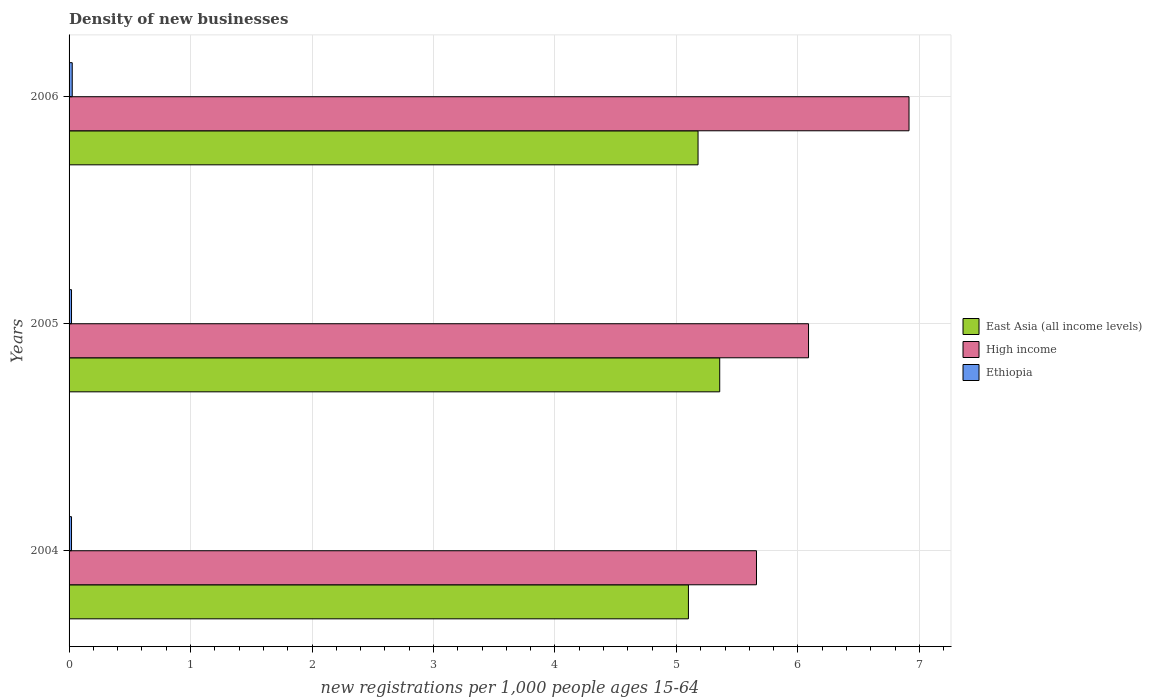How many groups of bars are there?
Your response must be concise. 3. How many bars are there on the 1st tick from the top?
Your response must be concise. 3. How many bars are there on the 2nd tick from the bottom?
Make the answer very short. 3. What is the label of the 1st group of bars from the top?
Offer a very short reply. 2006. In how many cases, is the number of bars for a given year not equal to the number of legend labels?
Your answer should be very brief. 0. What is the number of new registrations in Ethiopia in 2006?
Ensure brevity in your answer.  0.03. Across all years, what is the maximum number of new registrations in High income?
Offer a terse response. 6.91. Across all years, what is the minimum number of new registrations in East Asia (all income levels)?
Offer a very short reply. 5.1. In which year was the number of new registrations in High income maximum?
Your response must be concise. 2006. What is the total number of new registrations in Ethiopia in the graph?
Provide a succinct answer. 0.07. What is the difference between the number of new registrations in East Asia (all income levels) in 2005 and that in 2006?
Offer a very short reply. 0.18. What is the difference between the number of new registrations in High income in 2004 and the number of new registrations in East Asia (all income levels) in 2005?
Give a very brief answer. 0.3. What is the average number of new registrations in High income per year?
Provide a short and direct response. 6.22. In the year 2006, what is the difference between the number of new registrations in Ethiopia and number of new registrations in High income?
Make the answer very short. -6.89. What is the ratio of the number of new registrations in High income in 2004 to that in 2005?
Provide a succinct answer. 0.93. Is the number of new registrations in East Asia (all income levels) in 2004 less than that in 2005?
Your answer should be compact. Yes. Is the difference between the number of new registrations in Ethiopia in 2005 and 2006 greater than the difference between the number of new registrations in High income in 2005 and 2006?
Give a very brief answer. Yes. What is the difference between the highest and the second highest number of new registrations in Ethiopia?
Give a very brief answer. 0.01. What is the difference between the highest and the lowest number of new registrations in East Asia (all income levels)?
Give a very brief answer. 0.26. In how many years, is the number of new registrations in East Asia (all income levels) greater than the average number of new registrations in East Asia (all income levels) taken over all years?
Give a very brief answer. 1. What does the 1st bar from the top in 2006 represents?
Your answer should be compact. Ethiopia. Is it the case that in every year, the sum of the number of new registrations in East Asia (all income levels) and number of new registrations in Ethiopia is greater than the number of new registrations in High income?
Your answer should be very brief. No. Are all the bars in the graph horizontal?
Your answer should be very brief. Yes. What is the difference between two consecutive major ticks on the X-axis?
Your answer should be very brief. 1. Does the graph contain any zero values?
Offer a very short reply. No. What is the title of the graph?
Make the answer very short. Density of new businesses. What is the label or title of the X-axis?
Give a very brief answer. New registrations per 1,0 people ages 15-64. What is the new registrations per 1,000 people ages 15-64 of East Asia (all income levels) in 2004?
Offer a terse response. 5.1. What is the new registrations per 1,000 people ages 15-64 of High income in 2004?
Make the answer very short. 5.66. What is the new registrations per 1,000 people ages 15-64 in Ethiopia in 2004?
Give a very brief answer. 0.02. What is the new registrations per 1,000 people ages 15-64 in East Asia (all income levels) in 2005?
Provide a succinct answer. 5.36. What is the new registrations per 1,000 people ages 15-64 of High income in 2005?
Provide a succinct answer. 6.09. What is the new registrations per 1,000 people ages 15-64 of Ethiopia in 2005?
Your answer should be compact. 0.02. What is the new registrations per 1,000 people ages 15-64 of East Asia (all income levels) in 2006?
Your response must be concise. 5.18. What is the new registrations per 1,000 people ages 15-64 of High income in 2006?
Make the answer very short. 6.91. What is the new registrations per 1,000 people ages 15-64 of Ethiopia in 2006?
Your response must be concise. 0.03. Across all years, what is the maximum new registrations per 1,000 people ages 15-64 in East Asia (all income levels)?
Make the answer very short. 5.36. Across all years, what is the maximum new registrations per 1,000 people ages 15-64 of High income?
Your response must be concise. 6.91. Across all years, what is the maximum new registrations per 1,000 people ages 15-64 in Ethiopia?
Your response must be concise. 0.03. Across all years, what is the minimum new registrations per 1,000 people ages 15-64 in East Asia (all income levels)?
Keep it short and to the point. 5.1. Across all years, what is the minimum new registrations per 1,000 people ages 15-64 in High income?
Your response must be concise. 5.66. Across all years, what is the minimum new registrations per 1,000 people ages 15-64 of Ethiopia?
Make the answer very short. 0.02. What is the total new registrations per 1,000 people ages 15-64 of East Asia (all income levels) in the graph?
Give a very brief answer. 15.63. What is the total new registrations per 1,000 people ages 15-64 in High income in the graph?
Offer a terse response. 18.66. What is the total new registrations per 1,000 people ages 15-64 in Ethiopia in the graph?
Make the answer very short. 0.07. What is the difference between the new registrations per 1,000 people ages 15-64 of East Asia (all income levels) in 2004 and that in 2005?
Provide a short and direct response. -0.26. What is the difference between the new registrations per 1,000 people ages 15-64 in High income in 2004 and that in 2005?
Make the answer very short. -0.43. What is the difference between the new registrations per 1,000 people ages 15-64 in Ethiopia in 2004 and that in 2005?
Keep it short and to the point. -0. What is the difference between the new registrations per 1,000 people ages 15-64 of East Asia (all income levels) in 2004 and that in 2006?
Your answer should be very brief. -0.08. What is the difference between the new registrations per 1,000 people ages 15-64 in High income in 2004 and that in 2006?
Offer a very short reply. -1.26. What is the difference between the new registrations per 1,000 people ages 15-64 in Ethiopia in 2004 and that in 2006?
Your response must be concise. -0.01. What is the difference between the new registrations per 1,000 people ages 15-64 of East Asia (all income levels) in 2005 and that in 2006?
Make the answer very short. 0.18. What is the difference between the new registrations per 1,000 people ages 15-64 of High income in 2005 and that in 2006?
Provide a short and direct response. -0.83. What is the difference between the new registrations per 1,000 people ages 15-64 of Ethiopia in 2005 and that in 2006?
Your answer should be very brief. -0.01. What is the difference between the new registrations per 1,000 people ages 15-64 in East Asia (all income levels) in 2004 and the new registrations per 1,000 people ages 15-64 in High income in 2005?
Make the answer very short. -0.99. What is the difference between the new registrations per 1,000 people ages 15-64 in East Asia (all income levels) in 2004 and the new registrations per 1,000 people ages 15-64 in Ethiopia in 2005?
Make the answer very short. 5.08. What is the difference between the new registrations per 1,000 people ages 15-64 in High income in 2004 and the new registrations per 1,000 people ages 15-64 in Ethiopia in 2005?
Provide a short and direct response. 5.64. What is the difference between the new registrations per 1,000 people ages 15-64 of East Asia (all income levels) in 2004 and the new registrations per 1,000 people ages 15-64 of High income in 2006?
Offer a very short reply. -1.82. What is the difference between the new registrations per 1,000 people ages 15-64 in East Asia (all income levels) in 2004 and the new registrations per 1,000 people ages 15-64 in Ethiopia in 2006?
Make the answer very short. 5.07. What is the difference between the new registrations per 1,000 people ages 15-64 of High income in 2004 and the new registrations per 1,000 people ages 15-64 of Ethiopia in 2006?
Provide a succinct answer. 5.63. What is the difference between the new registrations per 1,000 people ages 15-64 of East Asia (all income levels) in 2005 and the new registrations per 1,000 people ages 15-64 of High income in 2006?
Make the answer very short. -1.56. What is the difference between the new registrations per 1,000 people ages 15-64 in East Asia (all income levels) in 2005 and the new registrations per 1,000 people ages 15-64 in Ethiopia in 2006?
Provide a short and direct response. 5.33. What is the difference between the new registrations per 1,000 people ages 15-64 of High income in 2005 and the new registrations per 1,000 people ages 15-64 of Ethiopia in 2006?
Give a very brief answer. 6.06. What is the average new registrations per 1,000 people ages 15-64 in East Asia (all income levels) per year?
Provide a short and direct response. 5.21. What is the average new registrations per 1,000 people ages 15-64 in High income per year?
Your response must be concise. 6.22. What is the average new registrations per 1,000 people ages 15-64 of Ethiopia per year?
Provide a succinct answer. 0.02. In the year 2004, what is the difference between the new registrations per 1,000 people ages 15-64 of East Asia (all income levels) and new registrations per 1,000 people ages 15-64 of High income?
Your answer should be compact. -0.56. In the year 2004, what is the difference between the new registrations per 1,000 people ages 15-64 of East Asia (all income levels) and new registrations per 1,000 people ages 15-64 of Ethiopia?
Keep it short and to the point. 5.08. In the year 2004, what is the difference between the new registrations per 1,000 people ages 15-64 in High income and new registrations per 1,000 people ages 15-64 in Ethiopia?
Your response must be concise. 5.64. In the year 2005, what is the difference between the new registrations per 1,000 people ages 15-64 in East Asia (all income levels) and new registrations per 1,000 people ages 15-64 in High income?
Ensure brevity in your answer.  -0.73. In the year 2005, what is the difference between the new registrations per 1,000 people ages 15-64 in East Asia (all income levels) and new registrations per 1,000 people ages 15-64 in Ethiopia?
Give a very brief answer. 5.34. In the year 2005, what is the difference between the new registrations per 1,000 people ages 15-64 in High income and new registrations per 1,000 people ages 15-64 in Ethiopia?
Your answer should be compact. 6.07. In the year 2006, what is the difference between the new registrations per 1,000 people ages 15-64 of East Asia (all income levels) and new registrations per 1,000 people ages 15-64 of High income?
Your response must be concise. -1.74. In the year 2006, what is the difference between the new registrations per 1,000 people ages 15-64 in East Asia (all income levels) and new registrations per 1,000 people ages 15-64 in Ethiopia?
Offer a terse response. 5.15. In the year 2006, what is the difference between the new registrations per 1,000 people ages 15-64 of High income and new registrations per 1,000 people ages 15-64 of Ethiopia?
Your answer should be compact. 6.89. What is the ratio of the new registrations per 1,000 people ages 15-64 in East Asia (all income levels) in 2004 to that in 2005?
Provide a succinct answer. 0.95. What is the ratio of the new registrations per 1,000 people ages 15-64 of High income in 2004 to that in 2005?
Your answer should be very brief. 0.93. What is the ratio of the new registrations per 1,000 people ages 15-64 in East Asia (all income levels) in 2004 to that in 2006?
Offer a terse response. 0.98. What is the ratio of the new registrations per 1,000 people ages 15-64 of High income in 2004 to that in 2006?
Offer a very short reply. 0.82. What is the ratio of the new registrations per 1,000 people ages 15-64 of Ethiopia in 2004 to that in 2006?
Your answer should be very brief. 0.77. What is the ratio of the new registrations per 1,000 people ages 15-64 of East Asia (all income levels) in 2005 to that in 2006?
Offer a very short reply. 1.03. What is the ratio of the new registrations per 1,000 people ages 15-64 of High income in 2005 to that in 2006?
Offer a very short reply. 0.88. What is the ratio of the new registrations per 1,000 people ages 15-64 of Ethiopia in 2005 to that in 2006?
Offer a very short reply. 0.77. What is the difference between the highest and the second highest new registrations per 1,000 people ages 15-64 of East Asia (all income levels)?
Provide a succinct answer. 0.18. What is the difference between the highest and the second highest new registrations per 1,000 people ages 15-64 of High income?
Your answer should be very brief. 0.83. What is the difference between the highest and the second highest new registrations per 1,000 people ages 15-64 of Ethiopia?
Provide a short and direct response. 0.01. What is the difference between the highest and the lowest new registrations per 1,000 people ages 15-64 in East Asia (all income levels)?
Offer a very short reply. 0.26. What is the difference between the highest and the lowest new registrations per 1,000 people ages 15-64 of High income?
Provide a succinct answer. 1.26. What is the difference between the highest and the lowest new registrations per 1,000 people ages 15-64 in Ethiopia?
Your answer should be compact. 0.01. 